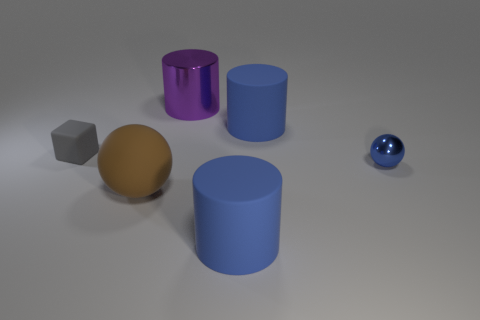The tiny blue sphere that is to the right of the large blue rubber object behind the ball that is behind the large brown matte thing is made of what material?
Ensure brevity in your answer.  Metal. There is a large rubber thing that is in front of the big object to the left of the big purple cylinder; what color is it?
Offer a very short reply. Blue. How many small objects are either blue cylinders or metallic spheres?
Ensure brevity in your answer.  1. How many purple cylinders are made of the same material as the blue sphere?
Your answer should be very brief. 1. There is a metal thing in front of the cube; what size is it?
Ensure brevity in your answer.  Small. There is a blue object that is on the right side of the big blue rubber object behind the small cube; what is its shape?
Make the answer very short. Sphere. There is a large blue rubber cylinder that is on the left side of the large matte cylinder behind the blue ball; what number of blue things are right of it?
Keep it short and to the point. 2. Are there fewer large purple metal objects that are to the left of the large sphere than spheres?
Your answer should be compact. Yes. Are there any other things that are the same shape as the gray object?
Offer a very short reply. No. The large blue rubber thing behind the small ball has what shape?
Make the answer very short. Cylinder. 